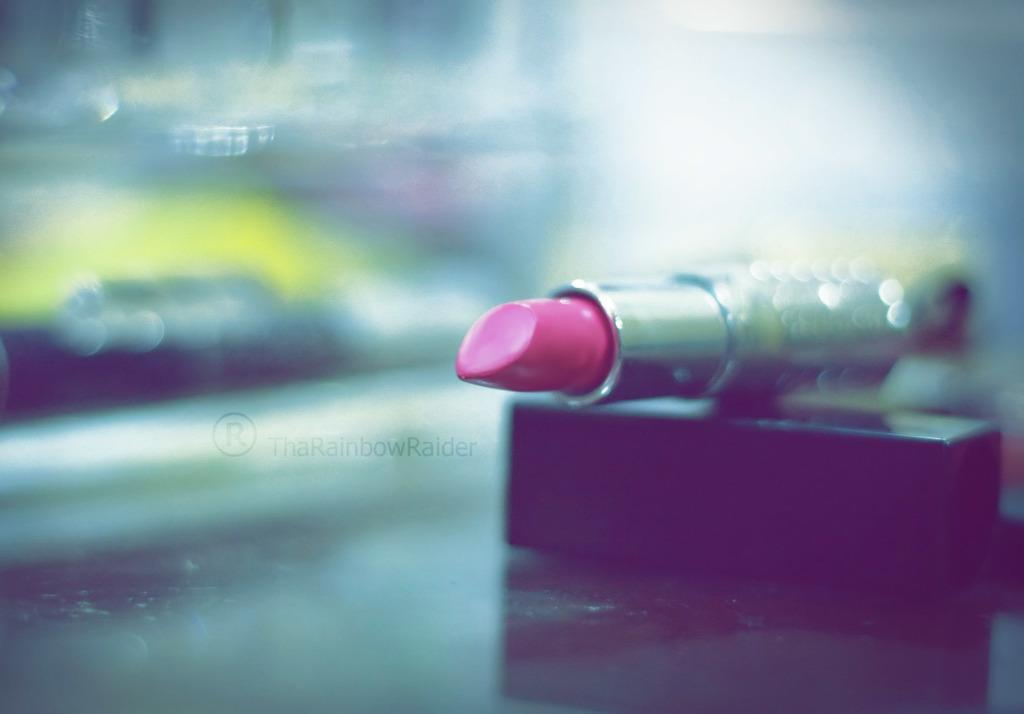What object is the main subject of the image? There is a lipstick in the image. What colors can be seen on the lipstick? The lipstick has pink and silver colors. What is the color of the surface the lipstick is on? The lipstick is on a black surface. How would you describe the background of the image? The background of the image is blurred. How many yams are present on the island in the image? There are no yams or islands present in the image; it features a lipstick on a black surface with a blurred background. 